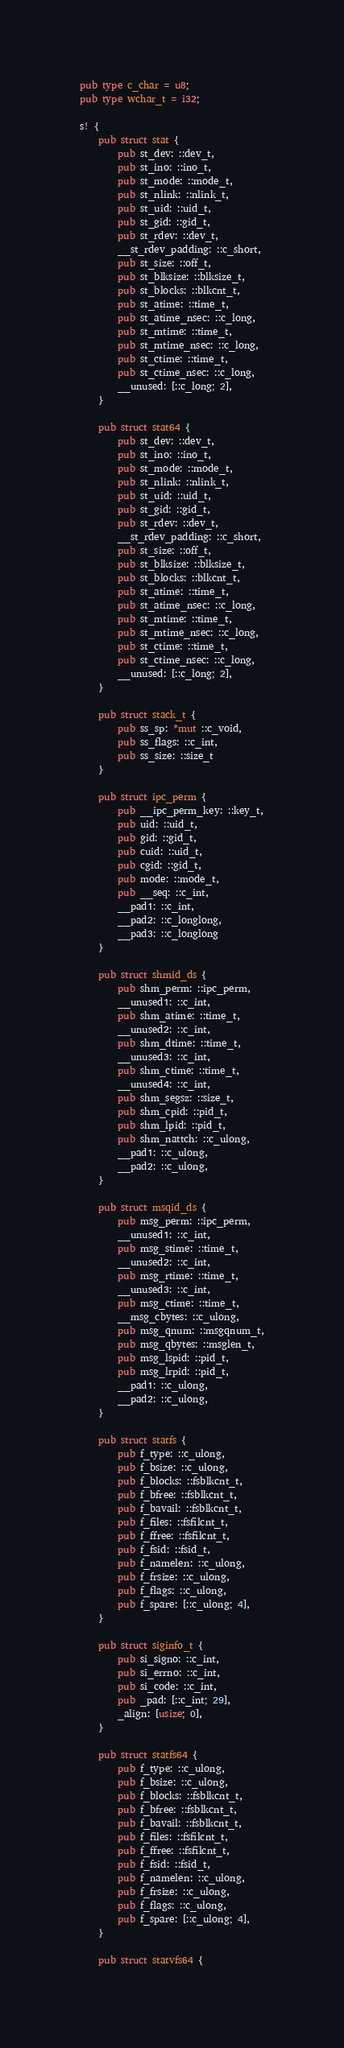Convert code to text. <code><loc_0><loc_0><loc_500><loc_500><_Rust_>pub type c_char = u8;
pub type wchar_t = i32;

s! {
    pub struct stat {
        pub st_dev: ::dev_t,
        pub st_ino: ::ino_t,
        pub st_mode: ::mode_t,
        pub st_nlink: ::nlink_t,
        pub st_uid: ::uid_t,
        pub st_gid: ::gid_t,
        pub st_rdev: ::dev_t,
        __st_rdev_padding: ::c_short,
        pub st_size: ::off_t,
        pub st_blksize: ::blksize_t,
        pub st_blocks: ::blkcnt_t,
        pub st_atime: ::time_t,
        pub st_atime_nsec: ::c_long,
        pub st_mtime: ::time_t,
        pub st_mtime_nsec: ::c_long,
        pub st_ctime: ::time_t,
        pub st_ctime_nsec: ::c_long,
        __unused: [::c_long; 2],
    }

    pub struct stat64 {
        pub st_dev: ::dev_t,
        pub st_ino: ::ino_t,
        pub st_mode: ::mode_t,
        pub st_nlink: ::nlink_t,
        pub st_uid: ::uid_t,
        pub st_gid: ::gid_t,
        pub st_rdev: ::dev_t,
        __st_rdev_padding: ::c_short,
        pub st_size: ::off_t,
        pub st_blksize: ::blksize_t,
        pub st_blocks: ::blkcnt_t,
        pub st_atime: ::time_t,
        pub st_atime_nsec: ::c_long,
        pub st_mtime: ::time_t,
        pub st_mtime_nsec: ::c_long,
        pub st_ctime: ::time_t,
        pub st_ctime_nsec: ::c_long,
        __unused: [::c_long; 2],
    }

    pub struct stack_t {
        pub ss_sp: *mut ::c_void,
        pub ss_flags: ::c_int,
        pub ss_size: ::size_t
    }

    pub struct ipc_perm {
        pub __ipc_perm_key: ::key_t,
        pub uid: ::uid_t,
        pub gid: ::gid_t,
        pub cuid: ::uid_t,
        pub cgid: ::gid_t,
        pub mode: ::mode_t,
        pub __seq: ::c_int,
        __pad1: ::c_int,
        __pad2: ::c_longlong,
        __pad3: ::c_longlong
    }

    pub struct shmid_ds {
        pub shm_perm: ::ipc_perm,
        __unused1: ::c_int,
        pub shm_atime: ::time_t,
        __unused2: ::c_int,
        pub shm_dtime: ::time_t,
        __unused3: ::c_int,
        pub shm_ctime: ::time_t,
        __unused4: ::c_int,
        pub shm_segsz: ::size_t,
        pub shm_cpid: ::pid_t,
        pub shm_lpid: ::pid_t,
        pub shm_nattch: ::c_ulong,
        __pad1: ::c_ulong,
        __pad2: ::c_ulong,
    }

    pub struct msqid_ds {
        pub msg_perm: ::ipc_perm,
        __unused1: ::c_int,
        pub msg_stime: ::time_t,
        __unused2: ::c_int,
        pub msg_rtime: ::time_t,
        __unused3: ::c_int,
        pub msg_ctime: ::time_t,
        __msg_cbytes: ::c_ulong,
        pub msg_qnum: ::msgqnum_t,
        pub msg_qbytes: ::msglen_t,
        pub msg_lspid: ::pid_t,
        pub msg_lrpid: ::pid_t,
        __pad1: ::c_ulong,
        __pad2: ::c_ulong,
    }

    pub struct statfs {
        pub f_type: ::c_ulong,
        pub f_bsize: ::c_ulong,
        pub f_blocks: ::fsblkcnt_t,
        pub f_bfree: ::fsblkcnt_t,
        pub f_bavail: ::fsblkcnt_t,
        pub f_files: ::fsfilcnt_t,
        pub f_ffree: ::fsfilcnt_t,
        pub f_fsid: ::fsid_t,
        pub f_namelen: ::c_ulong,
        pub f_frsize: ::c_ulong,
        pub f_flags: ::c_ulong,
        pub f_spare: [::c_ulong; 4],
    }

    pub struct siginfo_t {
        pub si_signo: ::c_int,
        pub si_errno: ::c_int,
        pub si_code: ::c_int,
        pub _pad: [::c_int; 29],
        _align: [usize; 0],
    }

    pub struct statfs64 {
        pub f_type: ::c_ulong,
        pub f_bsize: ::c_ulong,
        pub f_blocks: ::fsblkcnt_t,
        pub f_bfree: ::fsblkcnt_t,
        pub f_bavail: ::fsblkcnt_t,
        pub f_files: ::fsfilcnt_t,
        pub f_ffree: ::fsfilcnt_t,
        pub f_fsid: ::fsid_t,
        pub f_namelen: ::c_ulong,
        pub f_frsize: ::c_ulong,
        pub f_flags: ::c_ulong,
        pub f_spare: [::c_ulong; 4],
    }

    pub struct statvfs64 {</code> 